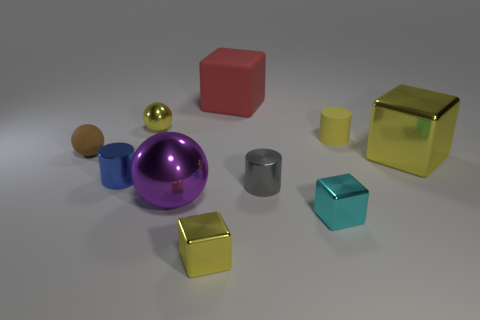Subtract all purple spheres. How many yellow blocks are left? 2 Subtract all small balls. How many balls are left? 1 Subtract all cyan blocks. How many blocks are left? 3 Subtract 1 blocks. How many blocks are left? 3 Subtract all brown blocks. Subtract all brown cylinders. How many blocks are left? 4 Subtract all blocks. How many objects are left? 6 Subtract 0 green spheres. How many objects are left? 10 Subtract all red rubber cubes. Subtract all gray shiny objects. How many objects are left? 8 Add 4 tiny yellow metallic things. How many tiny yellow metallic things are left? 6 Add 1 large rubber spheres. How many large rubber spheres exist? 1 